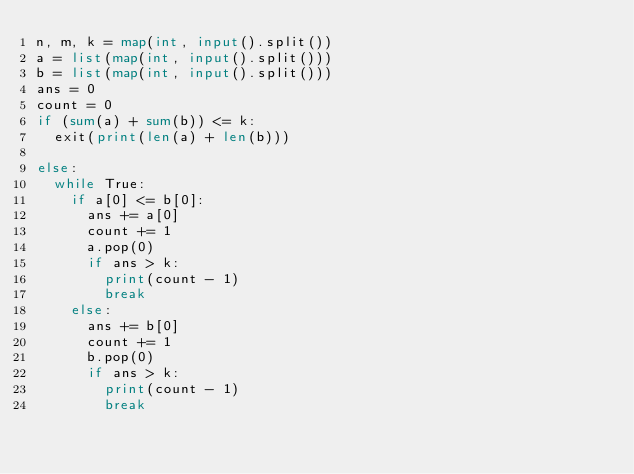<code> <loc_0><loc_0><loc_500><loc_500><_Python_>n, m, k = map(int, input().split())
a = list(map(int, input().split()))
b = list(map(int, input().split()))
ans = 0
count = 0
if (sum(a) + sum(b)) <= k:
  exit(print(len(a) + len(b)))
  
else:
  while True:
    if a[0] <= b[0]:
      ans += a[0]
      count += 1
      a.pop(0)
      if ans > k:
        print(count - 1)
        break
    else:
      ans += b[0]
      count += 1
      b.pop(0)
      if ans > k:
        print(count - 1)
        break</code> 